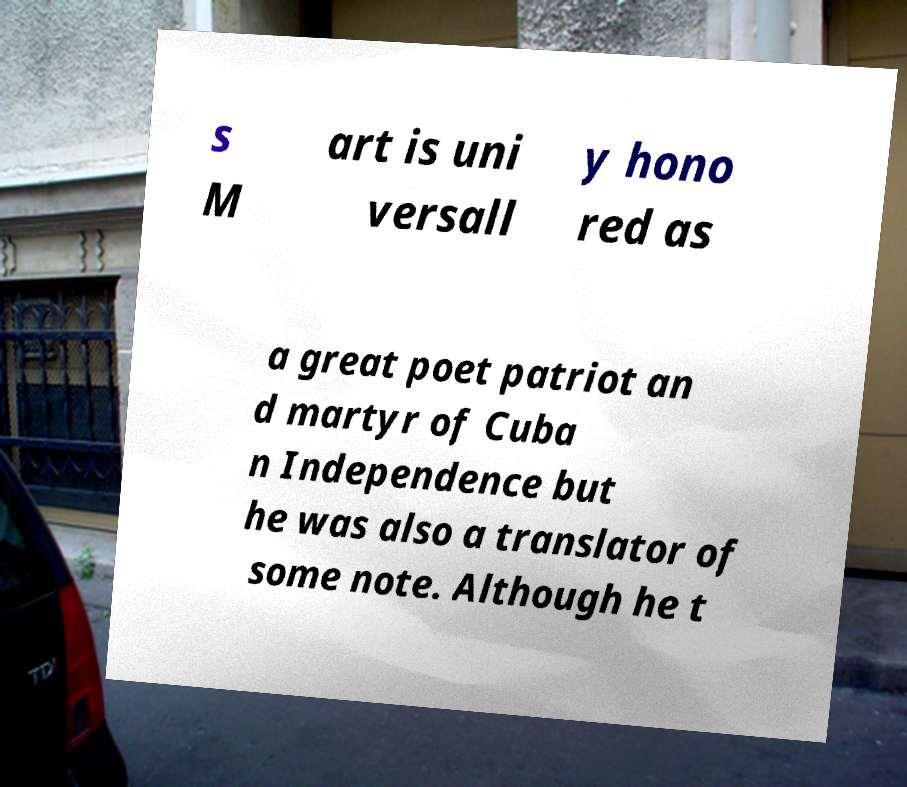There's text embedded in this image that I need extracted. Can you transcribe it verbatim? s M art is uni versall y hono red as a great poet patriot an d martyr of Cuba n Independence but he was also a translator of some note. Although he t 